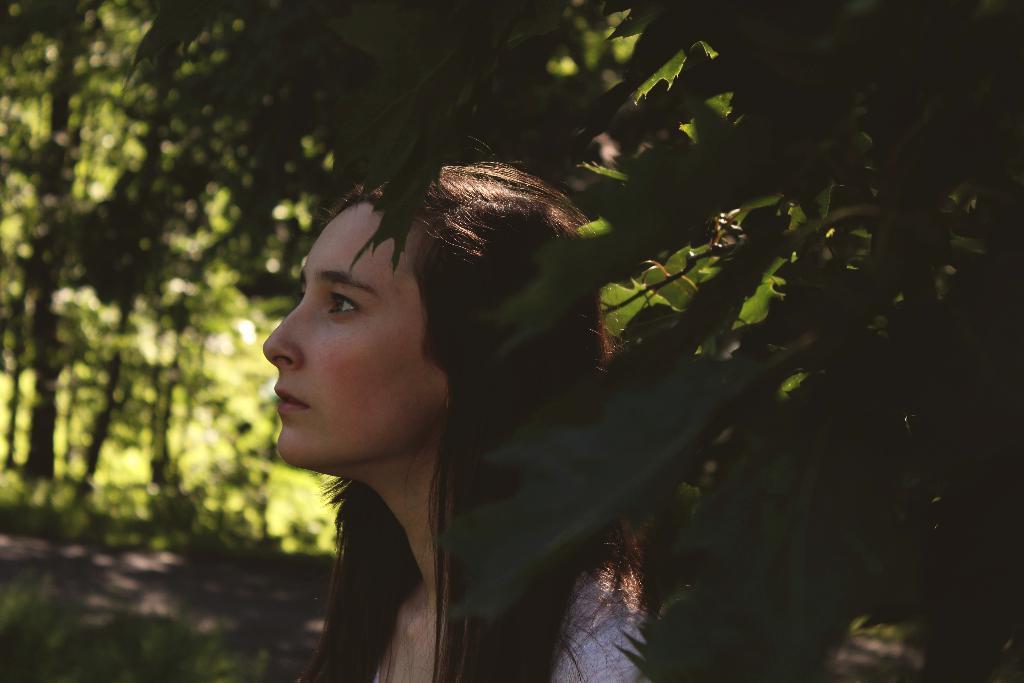How would you summarize this image in a sentence or two? In this image I can see a person and back I can see few green trees. 